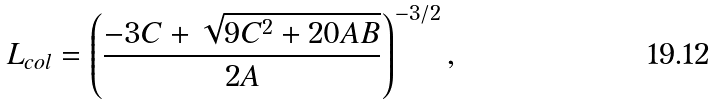Convert formula to latex. <formula><loc_0><loc_0><loc_500><loc_500>L _ { c o l } = \left ( \frac { - 3 C + \sqrt { 9 C ^ { 2 } + 2 0 A B } } { 2 A } \right ) ^ { - 3 / 2 } ,</formula> 